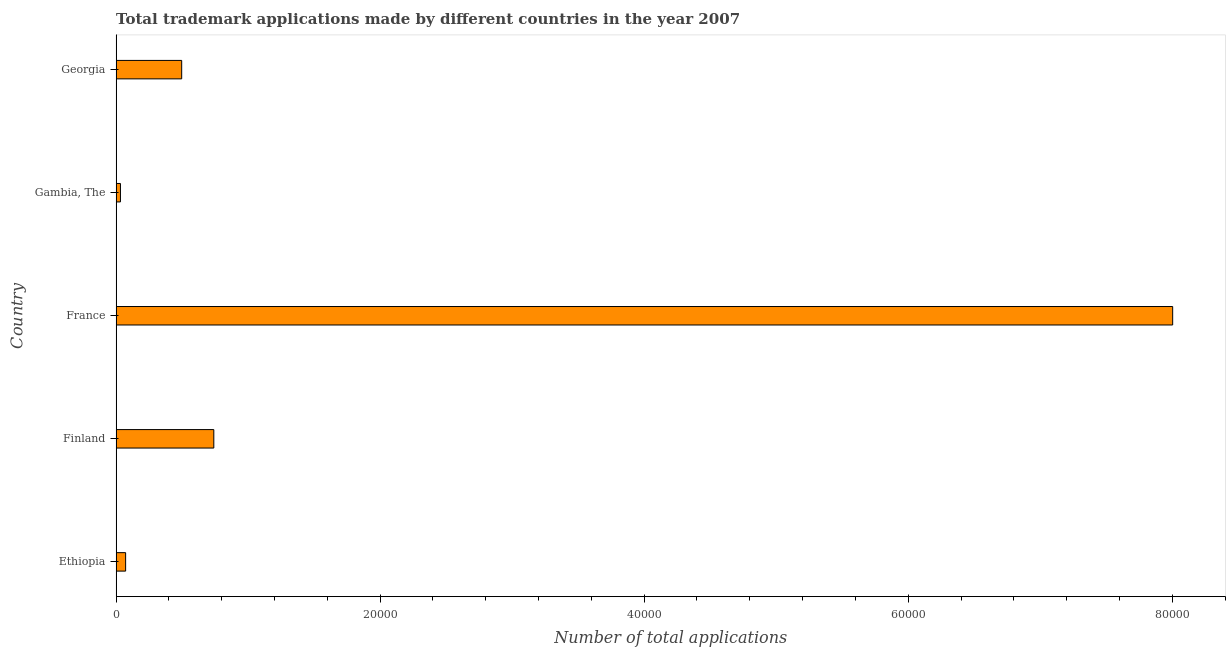What is the title of the graph?
Your answer should be very brief. Total trademark applications made by different countries in the year 2007. What is the label or title of the X-axis?
Offer a terse response. Number of total applications. What is the label or title of the Y-axis?
Your response must be concise. Country. What is the number of trademark applications in Gambia, The?
Offer a very short reply. 327. Across all countries, what is the maximum number of trademark applications?
Offer a very short reply. 8.00e+04. Across all countries, what is the minimum number of trademark applications?
Give a very brief answer. 327. In which country was the number of trademark applications minimum?
Offer a very short reply. Gambia, The. What is the sum of the number of trademark applications?
Provide a short and direct response. 9.34e+04. What is the difference between the number of trademark applications in Finland and Georgia?
Offer a terse response. 2434. What is the average number of trademark applications per country?
Your response must be concise. 1.87e+04. What is the median number of trademark applications?
Your answer should be compact. 4966. What is the ratio of the number of trademark applications in France to that in Gambia, The?
Give a very brief answer. 244.75. What is the difference between the highest and the second highest number of trademark applications?
Your answer should be very brief. 7.26e+04. Is the sum of the number of trademark applications in Finland and France greater than the maximum number of trademark applications across all countries?
Your answer should be compact. Yes. What is the difference between the highest and the lowest number of trademark applications?
Your answer should be compact. 7.97e+04. How many bars are there?
Provide a succinct answer. 5. Are the values on the major ticks of X-axis written in scientific E-notation?
Offer a terse response. No. What is the Number of total applications in Ethiopia?
Offer a very short reply. 719. What is the Number of total applications in Finland?
Keep it short and to the point. 7400. What is the Number of total applications in France?
Offer a very short reply. 8.00e+04. What is the Number of total applications in Gambia, The?
Provide a succinct answer. 327. What is the Number of total applications of Georgia?
Ensure brevity in your answer.  4966. What is the difference between the Number of total applications in Ethiopia and Finland?
Give a very brief answer. -6681. What is the difference between the Number of total applications in Ethiopia and France?
Offer a terse response. -7.93e+04. What is the difference between the Number of total applications in Ethiopia and Gambia, The?
Provide a succinct answer. 392. What is the difference between the Number of total applications in Ethiopia and Georgia?
Your answer should be compact. -4247. What is the difference between the Number of total applications in Finland and France?
Keep it short and to the point. -7.26e+04. What is the difference between the Number of total applications in Finland and Gambia, The?
Make the answer very short. 7073. What is the difference between the Number of total applications in Finland and Georgia?
Offer a very short reply. 2434. What is the difference between the Number of total applications in France and Gambia, The?
Ensure brevity in your answer.  7.97e+04. What is the difference between the Number of total applications in France and Georgia?
Your response must be concise. 7.51e+04. What is the difference between the Number of total applications in Gambia, The and Georgia?
Offer a very short reply. -4639. What is the ratio of the Number of total applications in Ethiopia to that in Finland?
Your response must be concise. 0.1. What is the ratio of the Number of total applications in Ethiopia to that in France?
Keep it short and to the point. 0.01. What is the ratio of the Number of total applications in Ethiopia to that in Gambia, The?
Provide a succinct answer. 2.2. What is the ratio of the Number of total applications in Ethiopia to that in Georgia?
Offer a terse response. 0.14. What is the ratio of the Number of total applications in Finland to that in France?
Your response must be concise. 0.09. What is the ratio of the Number of total applications in Finland to that in Gambia, The?
Ensure brevity in your answer.  22.63. What is the ratio of the Number of total applications in Finland to that in Georgia?
Give a very brief answer. 1.49. What is the ratio of the Number of total applications in France to that in Gambia, The?
Make the answer very short. 244.75. What is the ratio of the Number of total applications in France to that in Georgia?
Keep it short and to the point. 16.12. What is the ratio of the Number of total applications in Gambia, The to that in Georgia?
Ensure brevity in your answer.  0.07. 